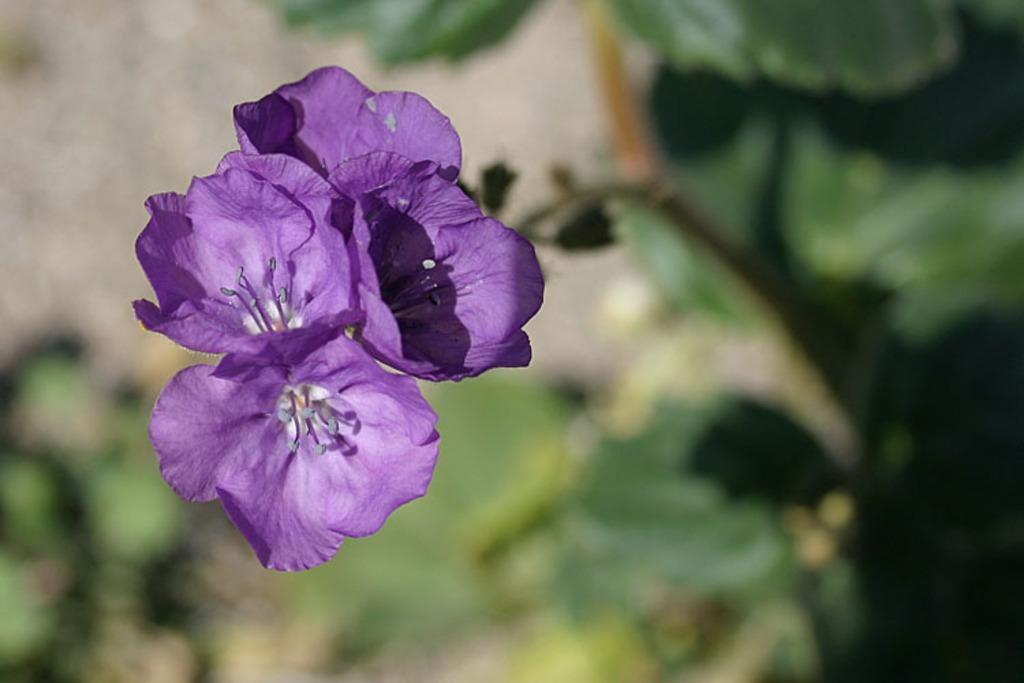What type of flowers can be seen in the image? There are purple color flowers in the image. What color is the background of the image? The background is in green color. How is the background of the image depicted? The background is blurred. What time is the baseball game starting in the image? There is no baseball game or any reference to time in the image. 